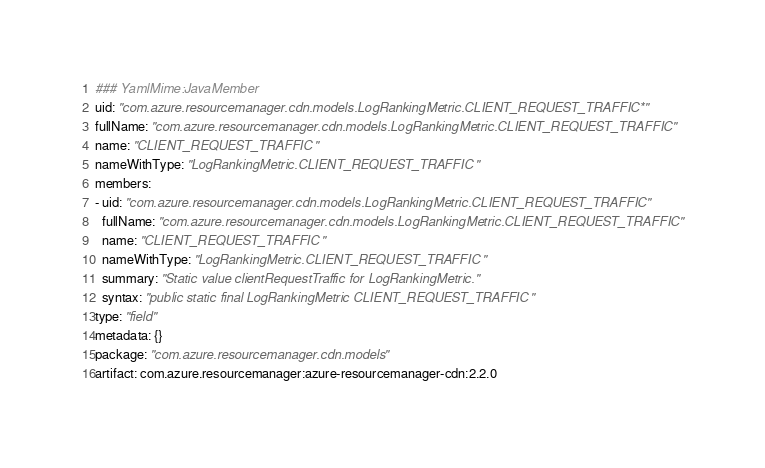Convert code to text. <code><loc_0><loc_0><loc_500><loc_500><_YAML_>### YamlMime:JavaMember
uid: "com.azure.resourcemanager.cdn.models.LogRankingMetric.CLIENT_REQUEST_TRAFFIC*"
fullName: "com.azure.resourcemanager.cdn.models.LogRankingMetric.CLIENT_REQUEST_TRAFFIC"
name: "CLIENT_REQUEST_TRAFFIC"
nameWithType: "LogRankingMetric.CLIENT_REQUEST_TRAFFIC"
members:
- uid: "com.azure.resourcemanager.cdn.models.LogRankingMetric.CLIENT_REQUEST_TRAFFIC"
  fullName: "com.azure.resourcemanager.cdn.models.LogRankingMetric.CLIENT_REQUEST_TRAFFIC"
  name: "CLIENT_REQUEST_TRAFFIC"
  nameWithType: "LogRankingMetric.CLIENT_REQUEST_TRAFFIC"
  summary: "Static value clientRequestTraffic for LogRankingMetric."
  syntax: "public static final LogRankingMetric CLIENT_REQUEST_TRAFFIC"
type: "field"
metadata: {}
package: "com.azure.resourcemanager.cdn.models"
artifact: com.azure.resourcemanager:azure-resourcemanager-cdn:2.2.0
</code> 